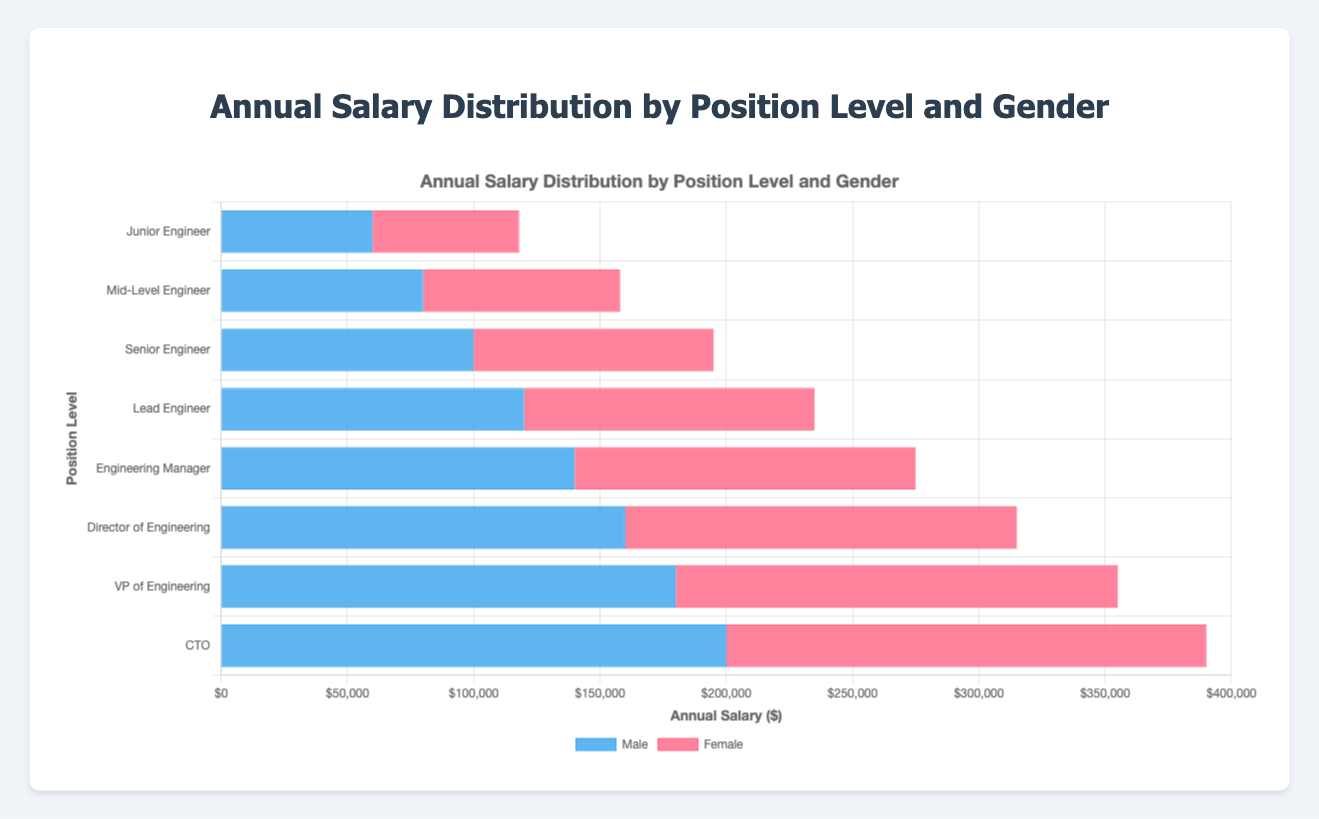What is the difference in annual salary between male and female Junior Engineers? To find the difference, subtract the female salary from the male salary for the Junior Engineer position. For Junior Engineers, the male salary is $60,000, and the female salary is $58,000. So, the difference is $60,000 - $58,000 = $2,000.
Answer: $2,000 Which gender has a higher salary at the Lead Engineer level? Compare the annual salary of male and female Lead Engineers. The male salary is $120,000, and the female salary is $115,000. Since $120,000 is greater than $115,000, males have a higher salary at the Lead Engineer level.
Answer: Male What is the combined annual salary of male and female Mid-Level Engineers? Sum the annual salaries of male and female Mid-Level Engineers. The male salary is $80,000, and the female salary is $78,000. Adding these together gives $80,000 + $78,000 = $158,000.
Answer: $158,000 Is the salary of female Engineering Managers closer to the salary of male Mid-Level Engineers or male Senior Engineers? Compare the difference between the female Engineering Manager's salary ($135,000) and the salaries of male Mid-Level Engineers ($80,000) and male Senior Engineers ($100,000). The differences are $135,000 - $80,000 = $55,000 and $135,000 - $100,000 = $35,000. The smaller difference is $35,000, so the female Engineering Manager's salary is closer to the male Senior Engineer's salary.
Answer: Male Senior Engineers What is the average annual salary for both males and females across all positions? Find the total annual salary for all males and females and then divide by the number of positions. Sum of male salaries: $60,000 + $80,000 + $100,000 + $120,000 + $140,000 + $160,000 + $180,000 + $200,000 = $1,040,000. Sum of female salaries: $58,000 + $78,000 + $95,000 + $115,000 + $135,000 + $155,000 + $175,000 + $190,000 = $1,001,000. Total sum: $1,040,000 + $1,001,000 = $2,041,000. Number of positions: 16. Average salary: $2,041,000 / 16 = $127,562.50.
Answer: $127,562.50 Which group has the highest salary difference based on gender, and what is that difference? Calculate the salary difference for each position level by subtracting the female salary from the male salary. Identify the position level with the highest difference. Differences are: Junior Engineer ($2,000), Mid-Level Engineer ($2,000), Senior Engineer ($5,000), Lead Engineer ($5,000), Engineering Manager ($5,000), Director of Engineering ($5,000), VP of Engineering ($5,000), CTO ($10,000). The highest difference is $10,000 for the CTO position.
Answer: CTO, $10,000 How does the salary of male and female Directors of Engineering compare to the salary of Mid-Level engineers? Compare the annual salary of male and female Directors of Engineering ($160,000 and $155,000 respectively) with that of male and female Mid-Level Engineers ($80,000 and $78,000). Both genders at the Director level earn significantly more than those at the Mid-Level Engineer level.
Answer: Directors of Engineering earn more In which position level is the smallest gender salary gap observed? Compare the salary gaps for each position level. The gaps are: Junior Engineer ($2,000), Mid-Level Engineer ($2,000), Senior Engineer ($5,000), Lead Engineer ($5,000), Engineering Manager ($5,000), Director of Engineering ($5,000), VP of Engineering ($5,000), CTO ($10,000). The smallest gaps, $2,000, are observed at the Junior Engineer and Mid-Level Engineer levels.
Answer: Junior Engineer and Mid-Level Engineer What is the total salary of all male positions compared to all female positions? Sum the male and female salaries separately and compare the totals. Total sum of male salaries: $1,040,000. Total sum of female salaries: $1,001,000. Males earn more in total.
Answer: Males earn more in total 